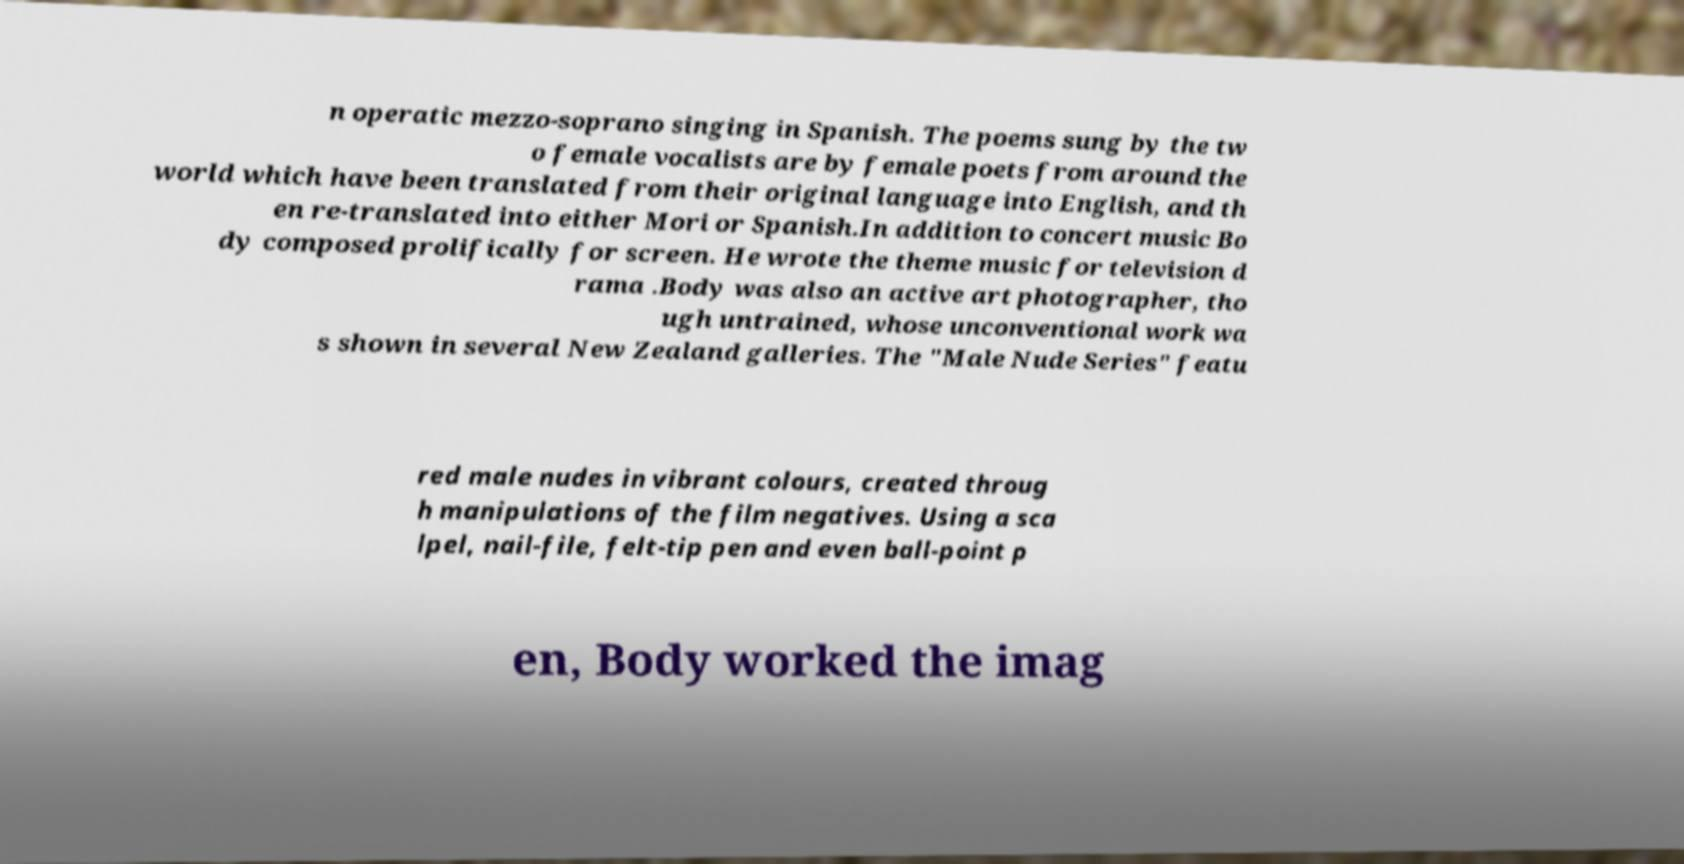Can you accurately transcribe the text from the provided image for me? n operatic mezzo-soprano singing in Spanish. The poems sung by the tw o female vocalists are by female poets from around the world which have been translated from their original language into English, and th en re-translated into either Mori or Spanish.In addition to concert music Bo dy composed prolifically for screen. He wrote the theme music for television d rama .Body was also an active art photographer, tho ugh untrained, whose unconventional work wa s shown in several New Zealand galleries. The "Male Nude Series" featu red male nudes in vibrant colours, created throug h manipulations of the film negatives. Using a sca lpel, nail-file, felt-tip pen and even ball-point p en, Body worked the imag 